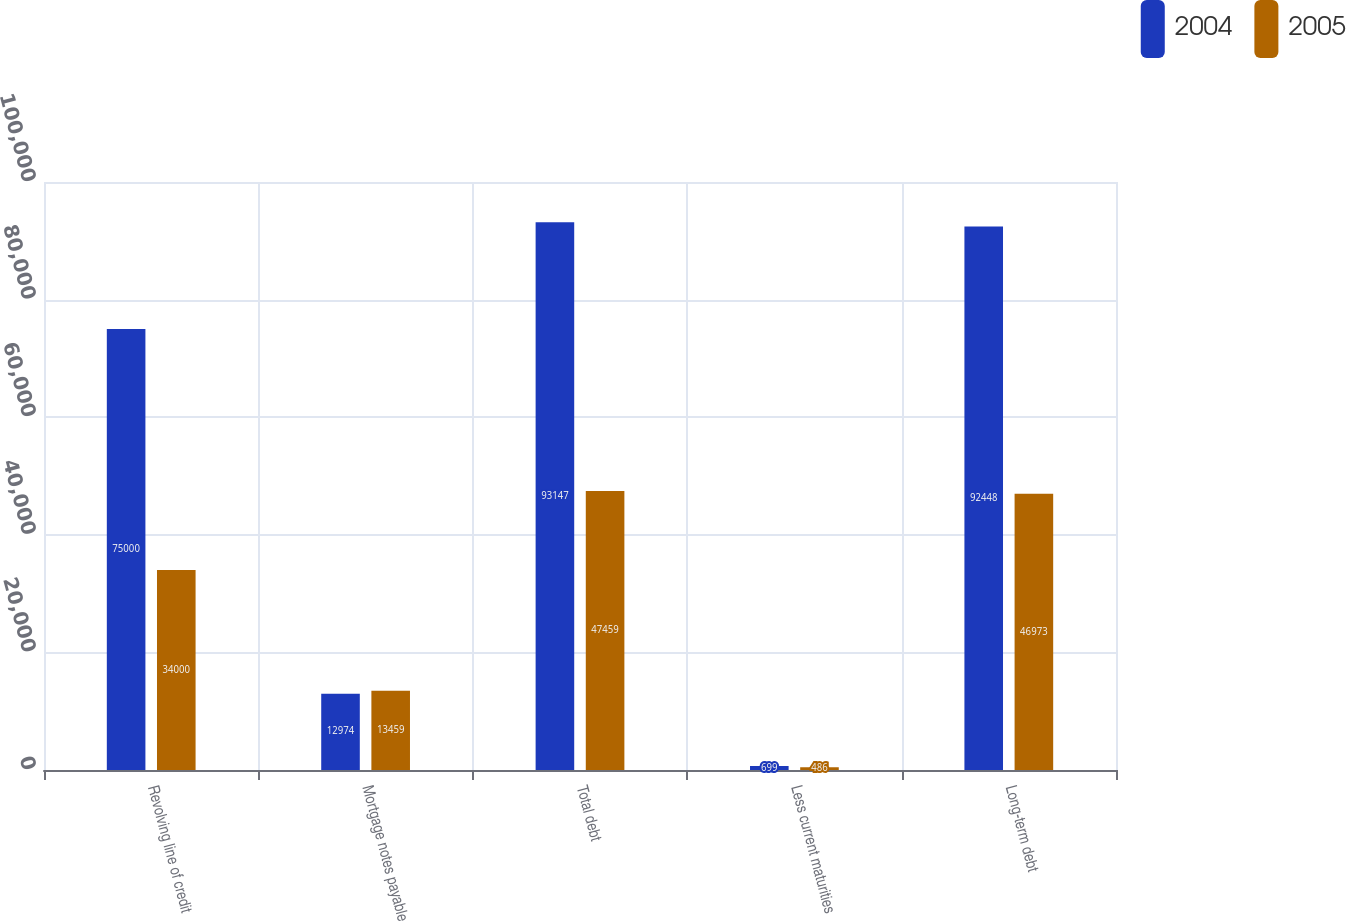<chart> <loc_0><loc_0><loc_500><loc_500><stacked_bar_chart><ecel><fcel>Revolving line of credit<fcel>Mortgage notes payable<fcel>Total debt<fcel>Less current maturities<fcel>Long-term debt<nl><fcel>2004<fcel>75000<fcel>12974<fcel>93147<fcel>699<fcel>92448<nl><fcel>2005<fcel>34000<fcel>13459<fcel>47459<fcel>486<fcel>46973<nl></chart> 